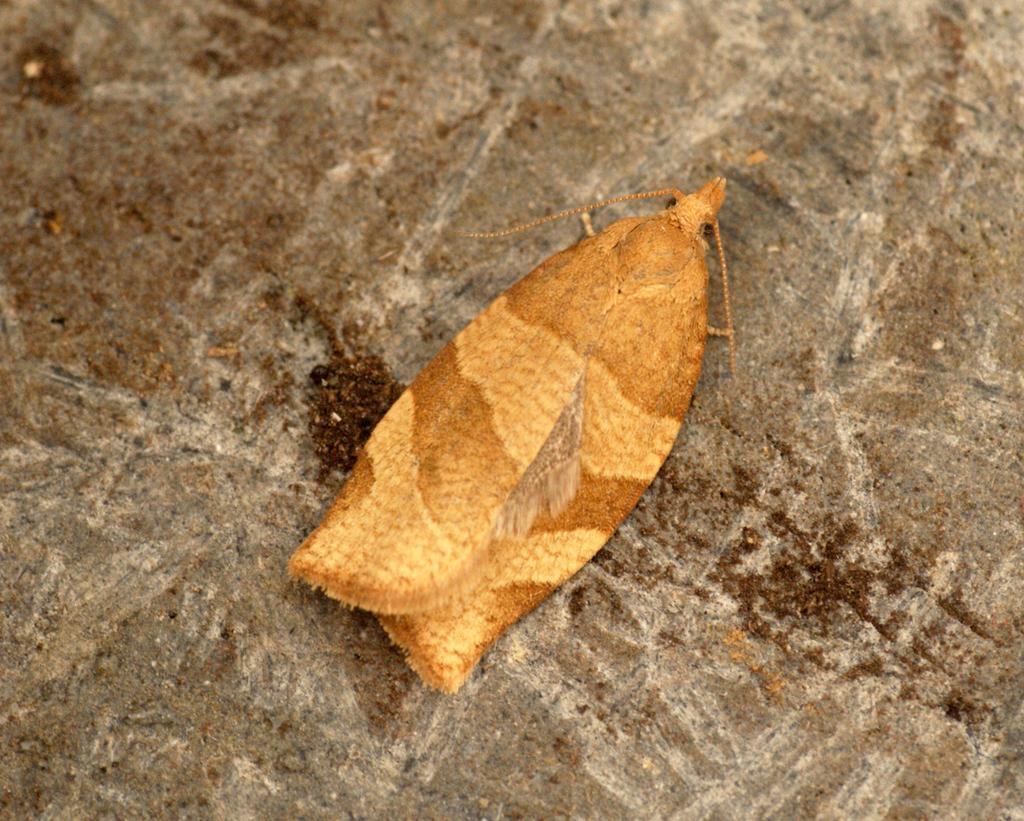What is present in the image? There is a fly in the image. Can you describe the appearance of the fly? The fly is brown in color. Where is the fly located in the image? The fly is on the ground. What type of camera is being used to take the picture of the fly? There is no information about a camera being used to take the picture, as the focus is on the fly itself. 